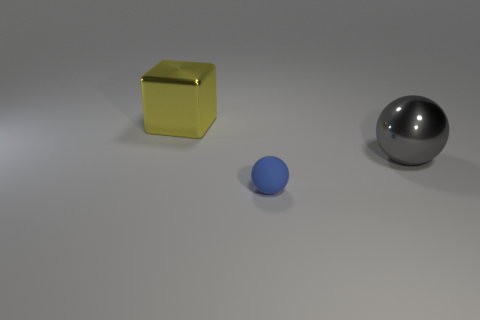Is there any other thing that is the same size as the rubber sphere?
Ensure brevity in your answer.  No. Are there any other purple balls that have the same material as the small ball?
Provide a succinct answer. No. Does the shiny block have the same size as the sphere on the left side of the gray thing?
Give a very brief answer. No. Do the small sphere and the yellow block have the same material?
Provide a short and direct response. No. There is a tiny matte sphere; how many objects are behind it?
Your response must be concise. 2. There is a thing that is to the right of the yellow block and on the left side of the large gray shiny sphere; what is it made of?
Keep it short and to the point. Rubber. How many blocks are the same size as the gray metallic object?
Keep it short and to the point. 1. What color is the large shiny thing that is in front of the big shiny object that is on the left side of the blue sphere?
Keep it short and to the point. Gray. Are there any blue shiny balls?
Provide a succinct answer. No. Is the shape of the blue matte object the same as the gray shiny thing?
Your response must be concise. Yes. 